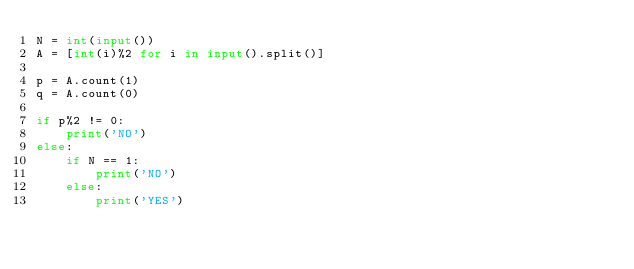<code> <loc_0><loc_0><loc_500><loc_500><_Python_>N = int(input())
A = [int(i)%2 for i in input().split()]

p = A.count(1)
q = A.count(0)

if p%2 != 0:
    print('NO')
else:
    if N == 1:
        print('NO')
    else:
        print('YES')
</code> 